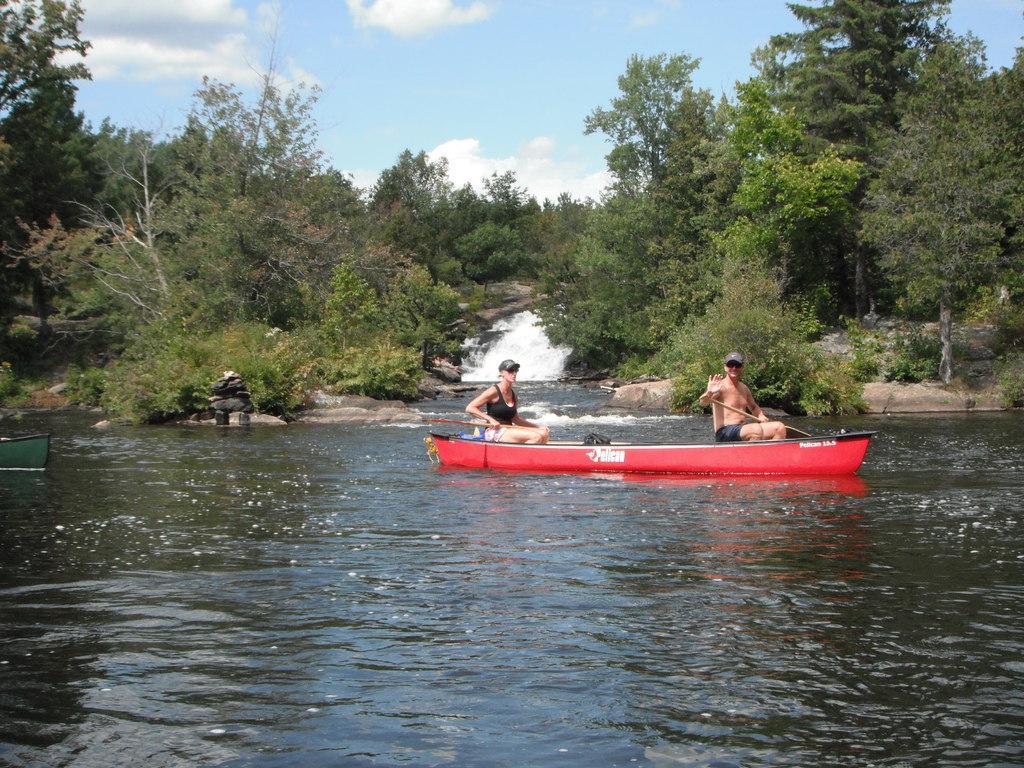Could you give a brief overview of what you see in this image? In this image there is water and we can see boats on the water. There are people sitting in the boat. In the background there are trees and sky. 